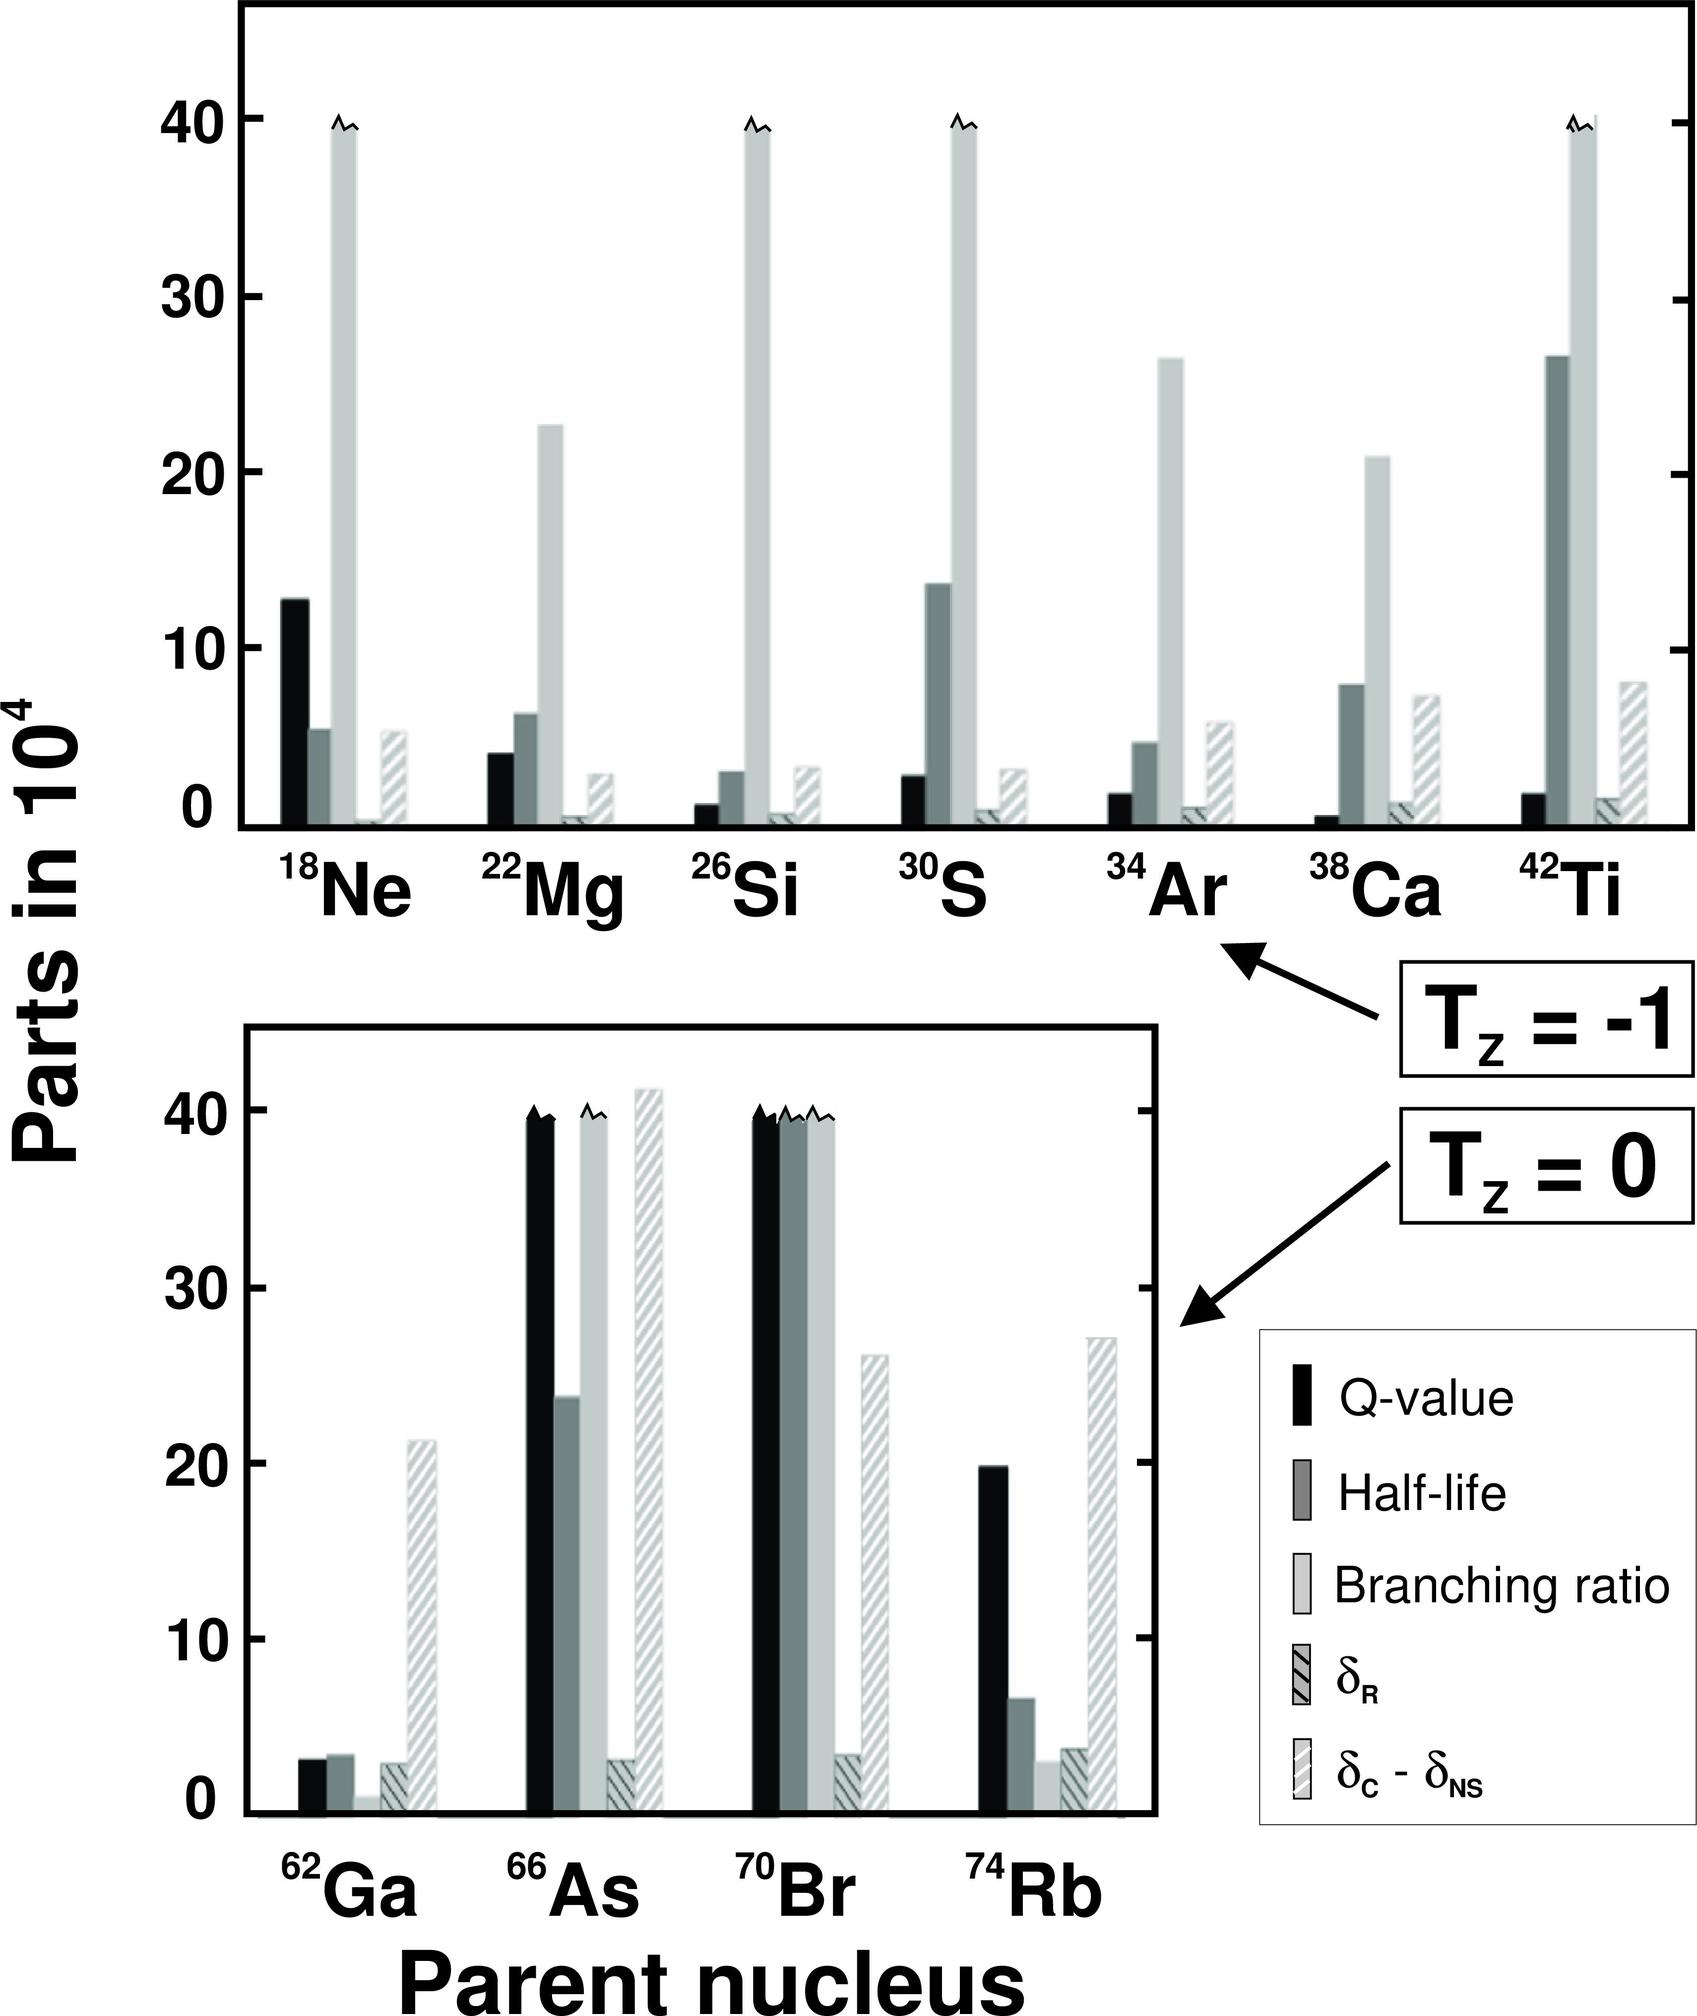Based on the given figure, which parent nucleus has the highest Q-value? A) \( ^{18}Ne \) B) \( ^{22}Mg \) C) \( ^{30}S \) D) \( ^{74}Rb \) Upon reviewing the graph, it becomes evident that the parent nucleus with the highest Q-value is \( ^{22}Mg \), which is represented by the tallest black bar in the upper section for T_z = -1 isotopes. The Q-value is a crucial measure of the energy release from nuclear reactions, and in this case, \( ^{22}Mg \) stands out as the most energetically favorable parent nucleus for beta-positive decay among those listed. Thus, the correct answer is B) \( ^{22}Mg \), indicating significant energy release potential in its decay process. 